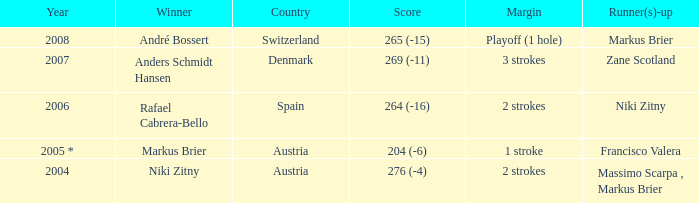Parse the table in full. {'header': ['Year', 'Winner', 'Country', 'Score', 'Margin', 'Runner(s)-up'], 'rows': [['2008', 'André Bossert', 'Switzerland', '265 (-15)', 'Playoff (1 hole)', 'Markus Brier'], ['2007', 'Anders Schmidt Hansen', 'Denmark', '269 (-11)', '3 strokes', 'Zane Scotland'], ['2006', 'Rafael Cabrera-Bello', 'Spain', '264 (-16)', '2 strokes', 'Niki Zitny'], ['2005 *', 'Markus Brier', 'Austria', '204 (-6)', '1 stroke', 'Francisco Valera'], ['2004', 'Niki Zitny', 'Austria', '276 (-4)', '2 strokes', 'Massimo Scarpa , Markus Brier']]} In which year was the score 204 (-6)? 2005 *. 